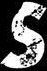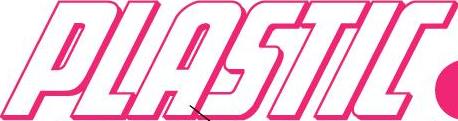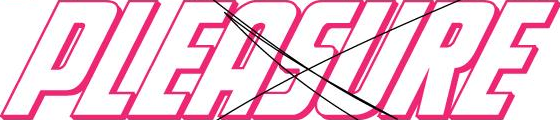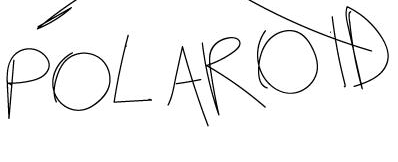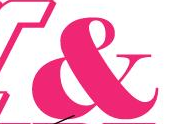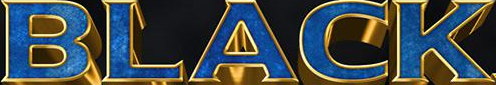Read the text from these images in sequence, separated by a semicolon. s; PLASTIC; PLEASURE; POLAROID; &; BLACK 